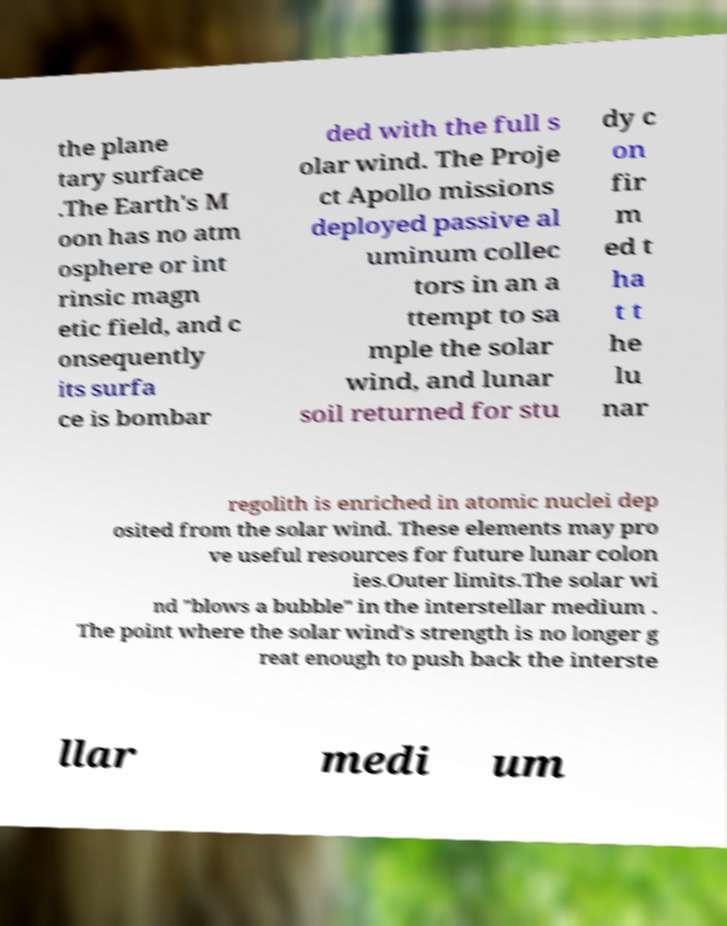Can you read and provide the text displayed in the image?This photo seems to have some interesting text. Can you extract and type it out for me? the plane tary surface .The Earth's M oon has no atm osphere or int rinsic magn etic field, and c onsequently its surfa ce is bombar ded with the full s olar wind. The Proje ct Apollo missions deployed passive al uminum collec tors in an a ttempt to sa mple the solar wind, and lunar soil returned for stu dy c on fir m ed t ha t t he lu nar regolith is enriched in atomic nuclei dep osited from the solar wind. These elements may pro ve useful resources for future lunar colon ies.Outer limits.The solar wi nd "blows a bubble" in the interstellar medium . The point where the solar wind's strength is no longer g reat enough to push back the interste llar medi um 